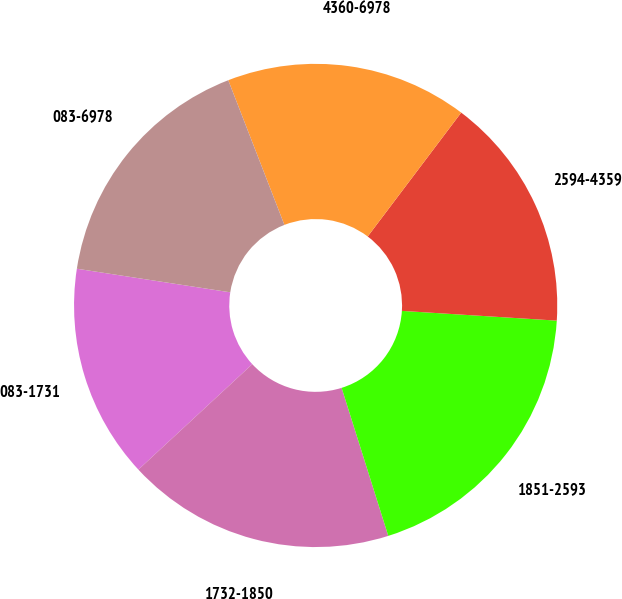<chart> <loc_0><loc_0><loc_500><loc_500><pie_chart><fcel>083-1731<fcel>1732-1850<fcel>1851-2593<fcel>2594-4359<fcel>4360-6978<fcel>083-6978<nl><fcel>14.32%<fcel>17.97%<fcel>19.14%<fcel>15.71%<fcel>16.18%<fcel>16.68%<nl></chart> 